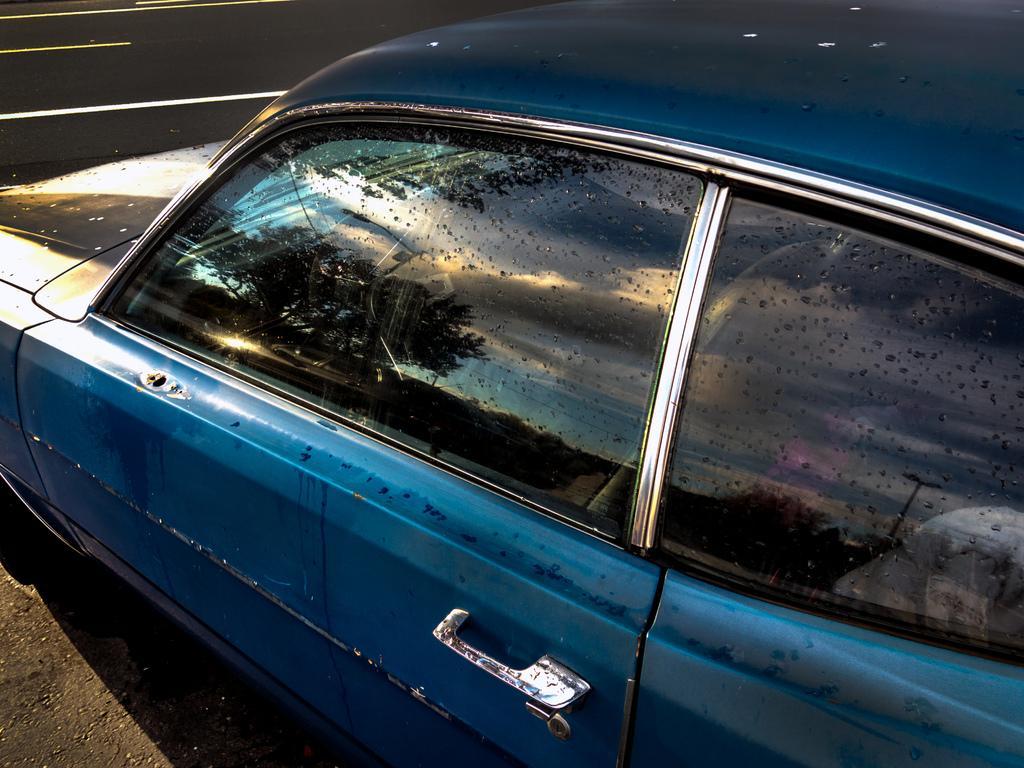How would you summarize this image in a sentence or two? There is a car in the foreground area of the image, there are trees and the sky reflecting in the glass. 